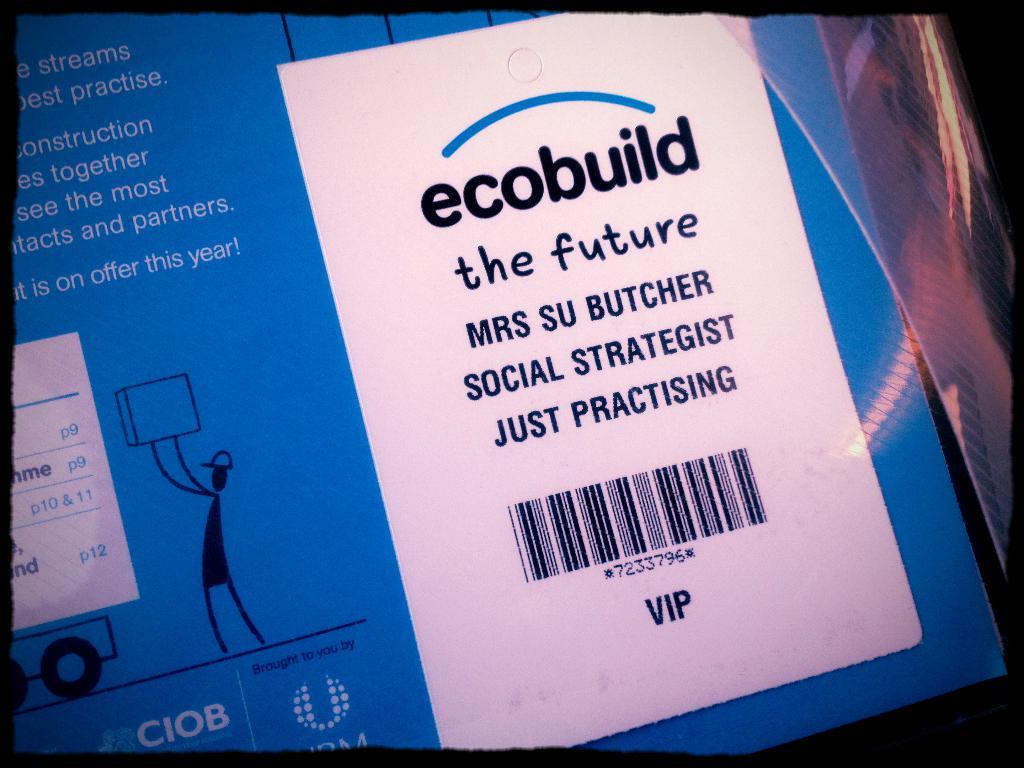<image>
Write a terse but informative summary of the picture. A label on a product labeled ecobuild and has the name Mrs. Su Butcher on it. 